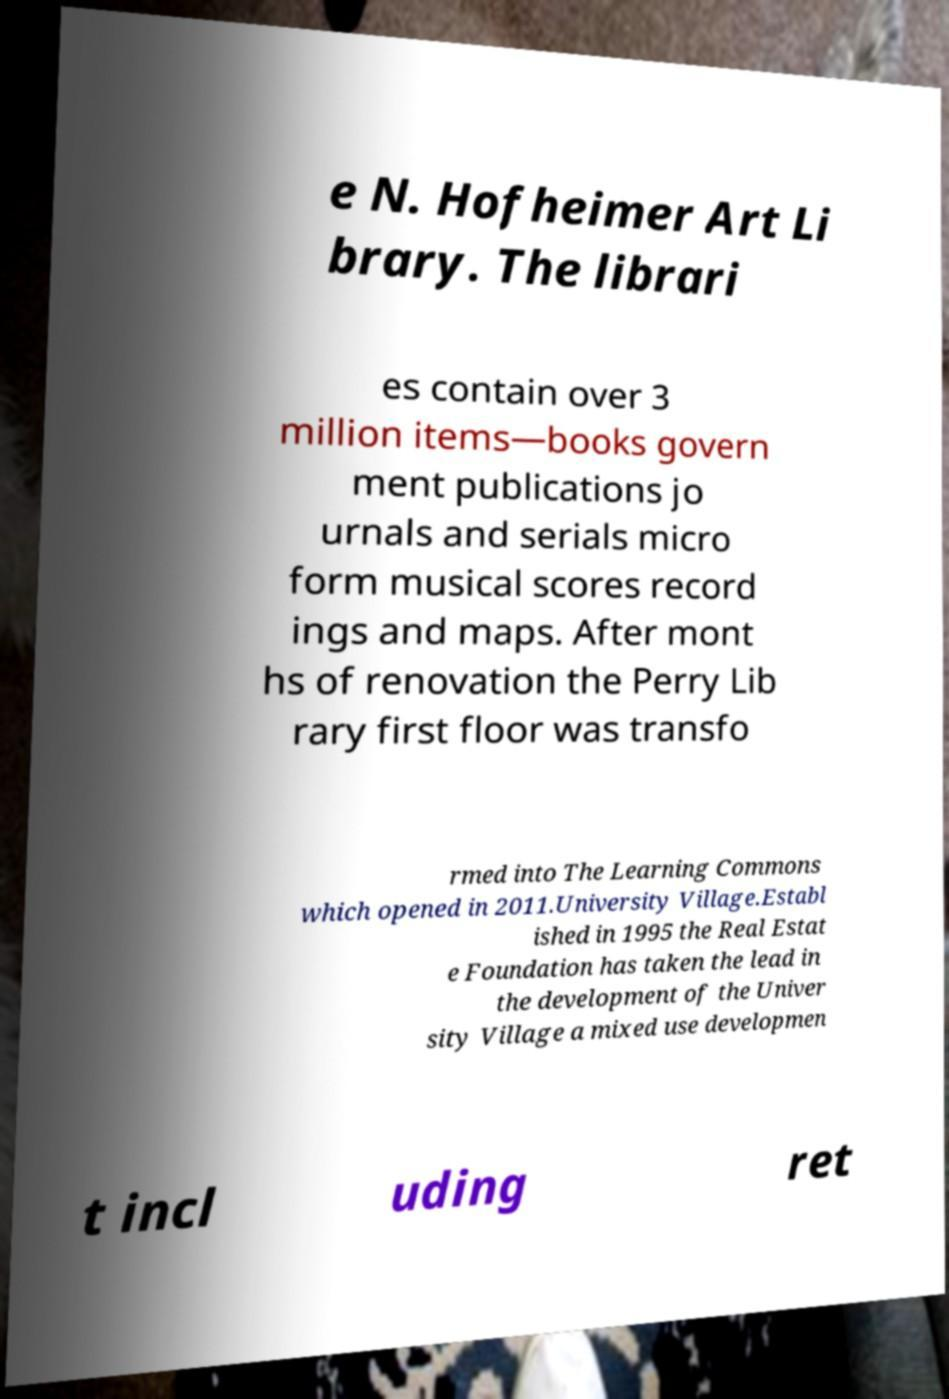What messages or text are displayed in this image? I need them in a readable, typed format. e N. Hofheimer Art Li brary. The librari es contain over 3 million items—books govern ment publications jo urnals and serials micro form musical scores record ings and maps. After mont hs of renovation the Perry Lib rary first floor was transfo rmed into The Learning Commons which opened in 2011.University Village.Establ ished in 1995 the Real Estat e Foundation has taken the lead in the development of the Univer sity Village a mixed use developmen t incl uding ret 